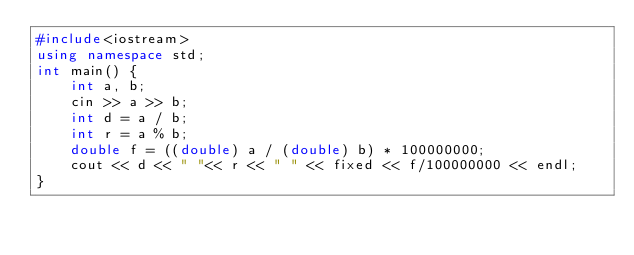Convert code to text. <code><loc_0><loc_0><loc_500><loc_500><_C++_>#include<iostream>
using namespace std;
int main() {
    int a, b;
    cin >> a >> b;
    int d = a / b;
    int r = a % b;
    double f = ((double) a / (double) b) * 100000000;
    cout << d << " "<< r << " " << fixed << f/100000000 << endl;
}
</code> 